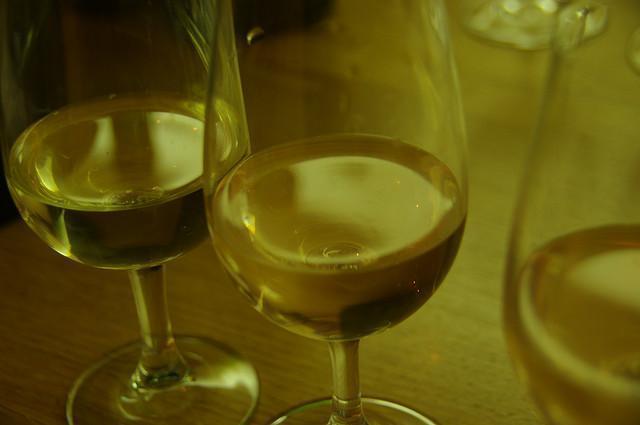How many glasses are there?
Give a very brief answer. 3. How many wine glasses are in the photo?
Give a very brief answer. 4. 